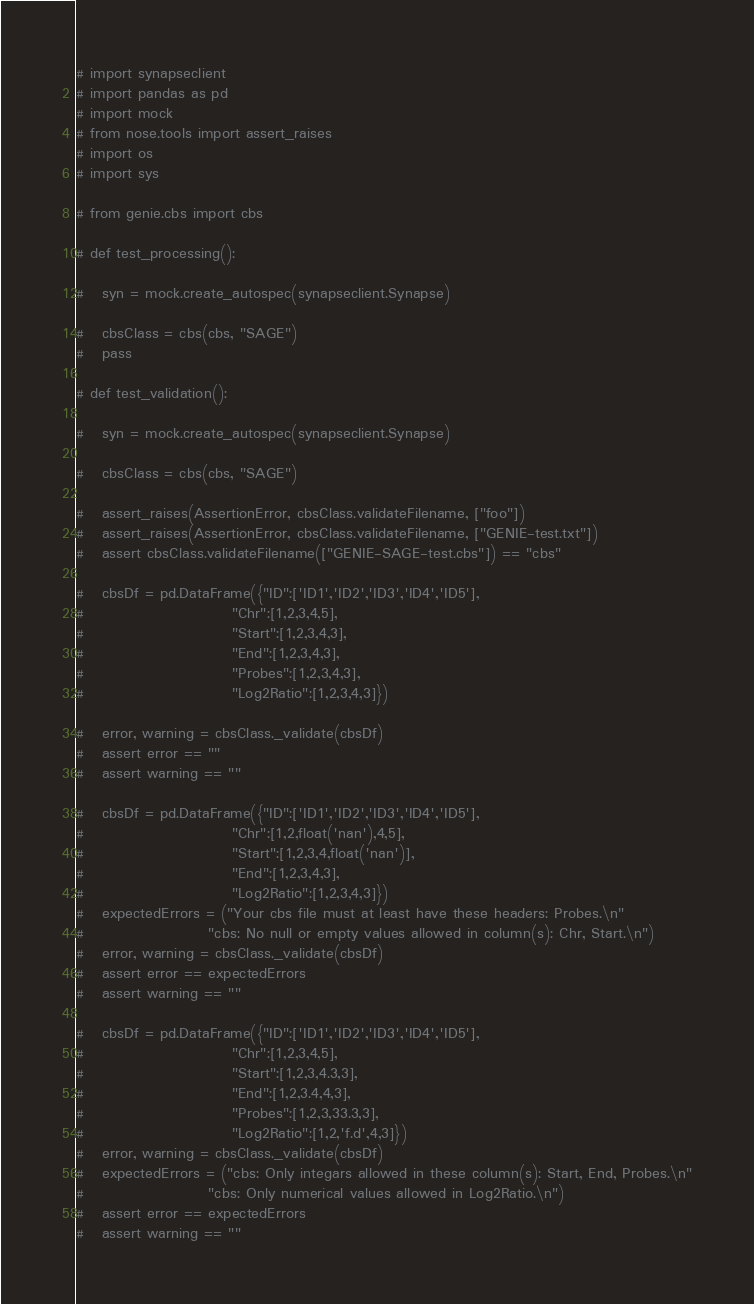<code> <loc_0><loc_0><loc_500><loc_500><_Python_># import synapseclient
# import pandas as pd
# import mock
# from nose.tools import assert_raises
# import os
# import sys

# from genie.cbs import cbs

# def test_processing():

#   syn = mock.create_autospec(synapseclient.Synapse) 

#   cbsClass = cbs(cbs, "SAGE")
#   pass

# def test_validation():

#   syn = mock.create_autospec(synapseclient.Synapse) 

#   cbsClass = cbs(cbs, "SAGE")

#   assert_raises(AssertionError, cbsClass.validateFilename, ["foo"])
#   assert_raises(AssertionError, cbsClass.validateFilename, ["GENIE-test.txt"])
#   assert cbsClass.validateFilename(["GENIE-SAGE-test.cbs"]) == "cbs"

#   cbsDf = pd.DataFrame({"ID":['ID1','ID2','ID3','ID4','ID5'],
#                         "Chr":[1,2,3,4,5],
#                         "Start":[1,2,3,4,3],
#                         "End":[1,2,3,4,3],
#                         "Probes":[1,2,3,4,3],
#                         "Log2Ratio":[1,2,3,4,3]})

#   error, warning = cbsClass._validate(cbsDf)
#   assert error == ""
#   assert warning == ""

#   cbsDf = pd.DataFrame({"ID":['ID1','ID2','ID3','ID4','ID5'],
#                         "Chr":[1,2,float('nan'),4,5],
#                         "Start":[1,2,3,4,float('nan')],
#                         "End":[1,2,3,4,3],
#                         "Log2Ratio":[1,2,3,4,3]})
#   expectedErrors = ("Your cbs file must at least have these headers: Probes.\n"
#                     "cbs: No null or empty values allowed in column(s): Chr, Start.\n")
#   error, warning = cbsClass._validate(cbsDf)
#   assert error == expectedErrors
#   assert warning == ""

#   cbsDf = pd.DataFrame({"ID":['ID1','ID2','ID3','ID4','ID5'],
#                         "Chr":[1,2,3,4,5],
#                         "Start":[1,2,3,4.3,3],
#                         "End":[1,2,3.4,4,3],
#                         "Probes":[1,2,3,33.3,3],
#                         "Log2Ratio":[1,2,'f.d',4,3]})
#   error, warning = cbsClass._validate(cbsDf)
#   expectedErrors = ("cbs: Only integars allowed in these column(s): Start, End, Probes.\n"
#                     "cbs: Only numerical values allowed in Log2Ratio.\n")
#   assert error == expectedErrors
#   assert warning == ""

</code> 